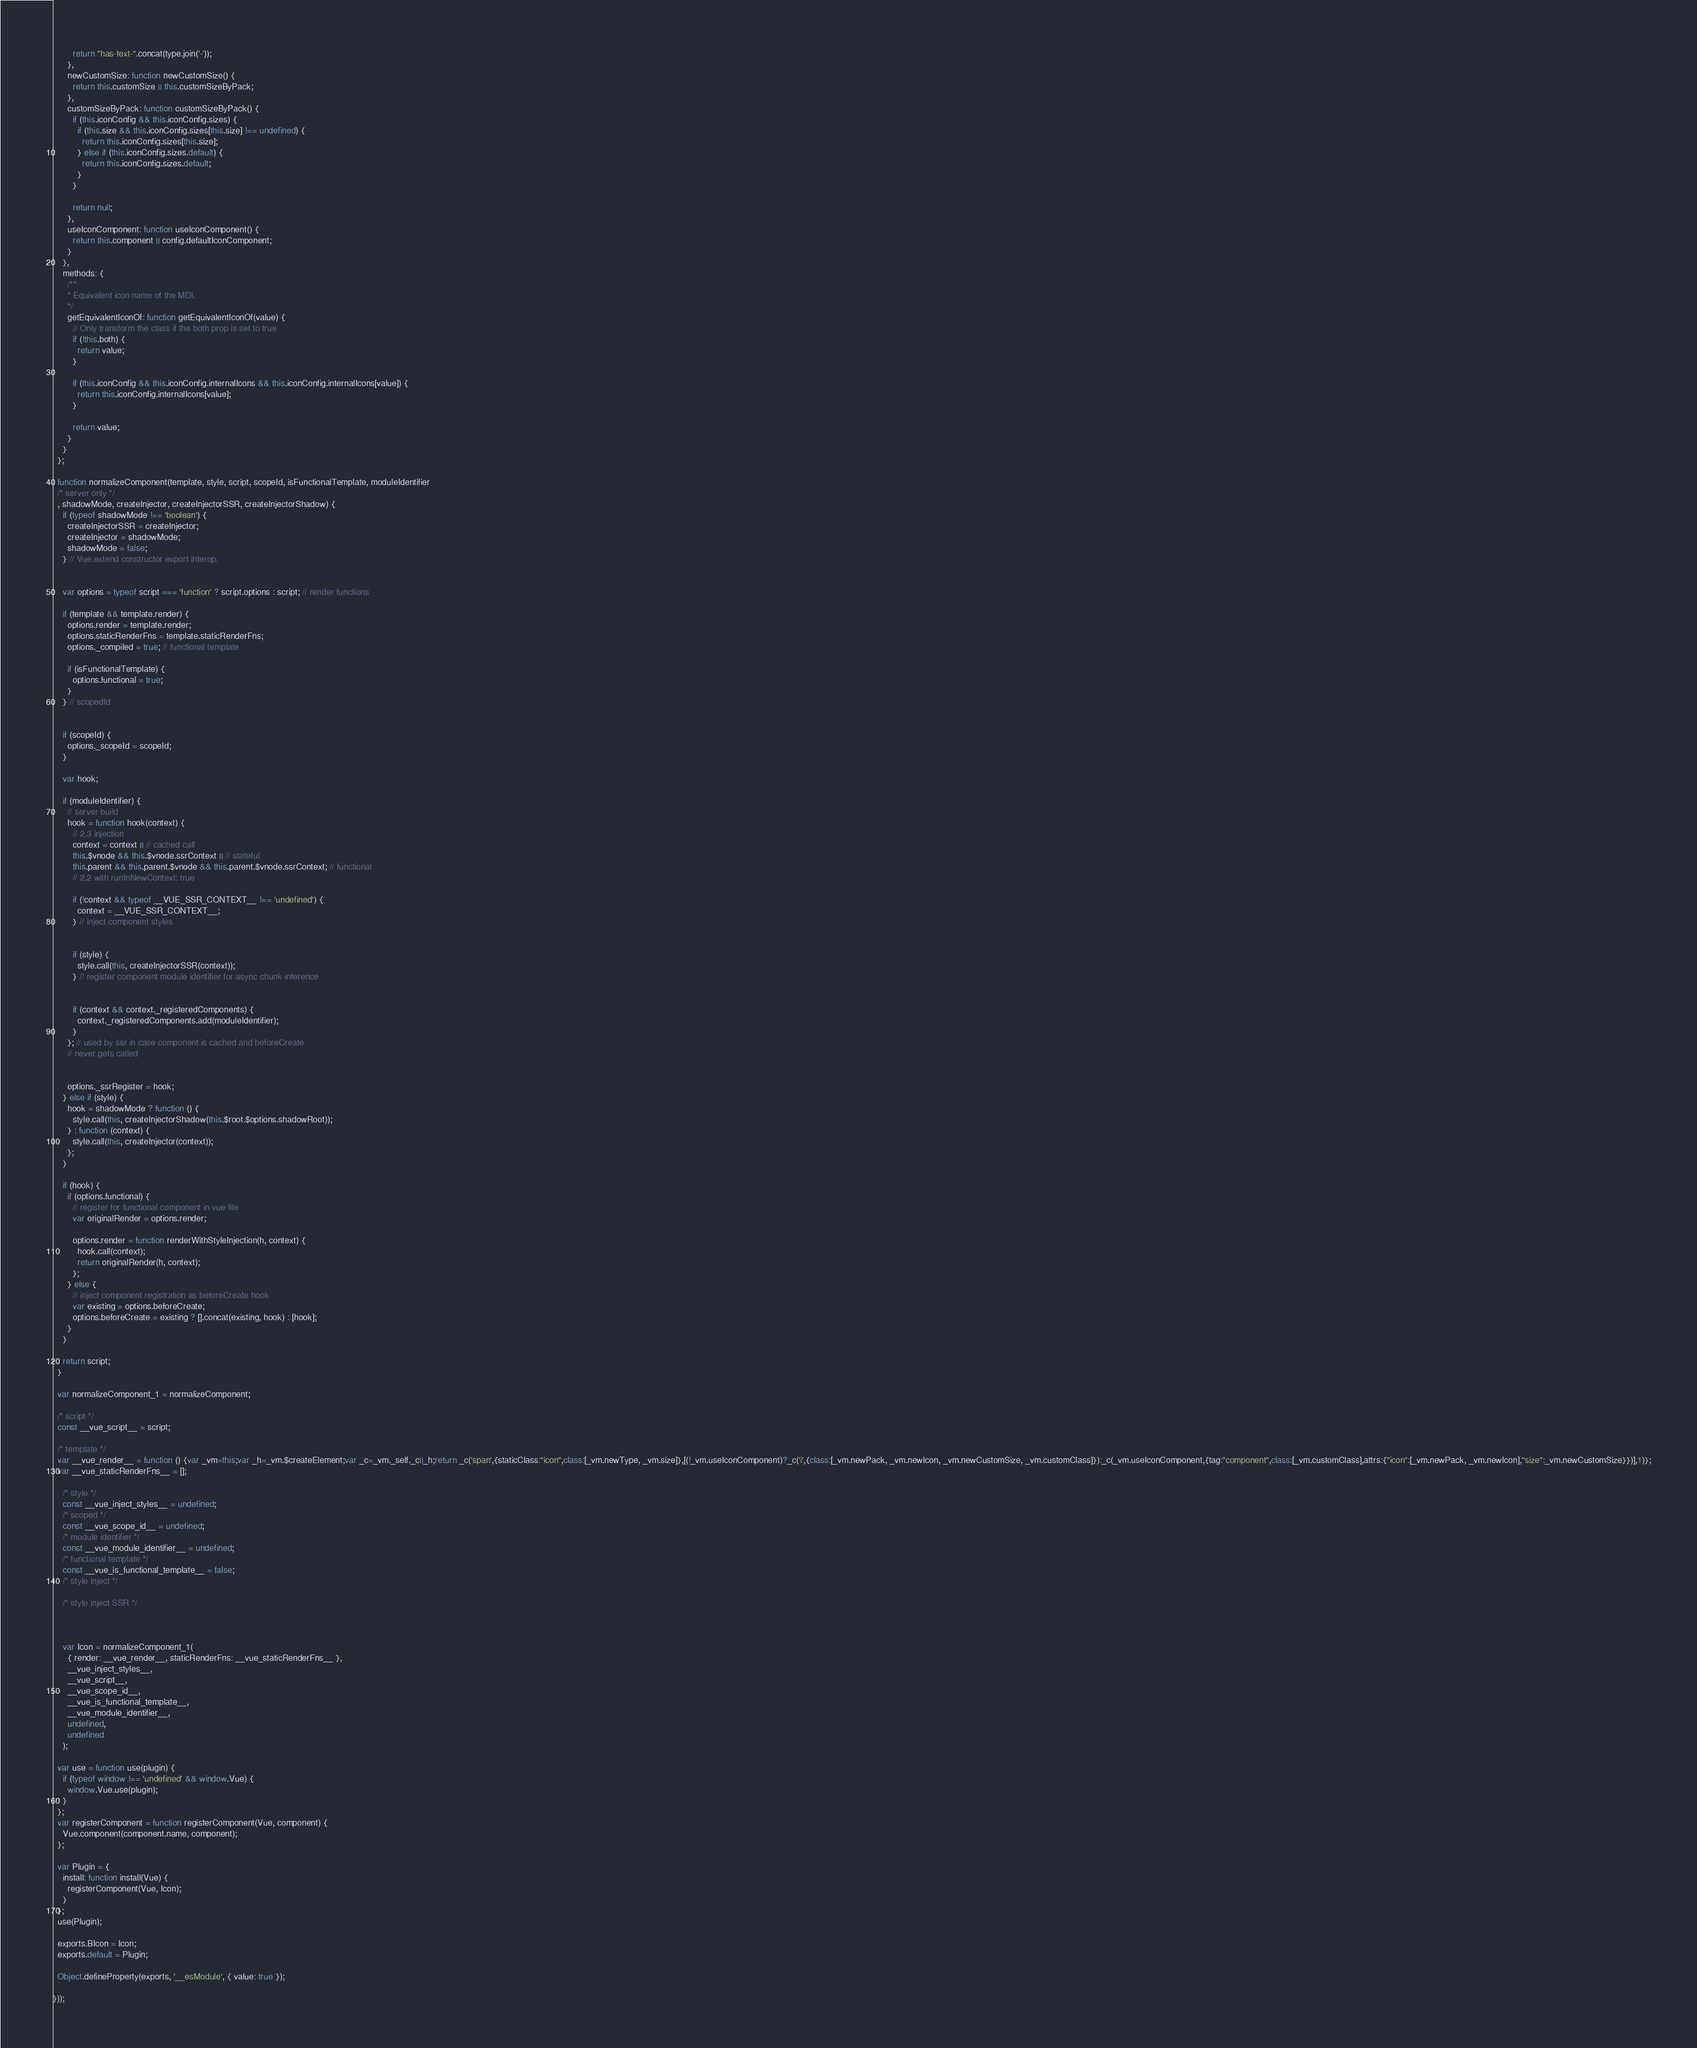<code> <loc_0><loc_0><loc_500><loc_500><_JavaScript_>
        return "has-text-".concat(type.join('-'));
      },
      newCustomSize: function newCustomSize() {
        return this.customSize || this.customSizeByPack;
      },
      customSizeByPack: function customSizeByPack() {
        if (this.iconConfig && this.iconConfig.sizes) {
          if (this.size && this.iconConfig.sizes[this.size] !== undefined) {
            return this.iconConfig.sizes[this.size];
          } else if (this.iconConfig.sizes.default) {
            return this.iconConfig.sizes.default;
          }
        }

        return null;
      },
      useIconComponent: function useIconComponent() {
        return this.component || config.defaultIconComponent;
      }
    },
    methods: {
      /**
      * Equivalent icon name of the MDI.
      */
      getEquivalentIconOf: function getEquivalentIconOf(value) {
        // Only transform the class if the both prop is set to true
        if (!this.both) {
          return value;
        }

        if (this.iconConfig && this.iconConfig.internalIcons && this.iconConfig.internalIcons[value]) {
          return this.iconConfig.internalIcons[value];
        }

        return value;
      }
    }
  };

  function normalizeComponent(template, style, script, scopeId, isFunctionalTemplate, moduleIdentifier
  /* server only */
  , shadowMode, createInjector, createInjectorSSR, createInjectorShadow) {
    if (typeof shadowMode !== 'boolean') {
      createInjectorSSR = createInjector;
      createInjector = shadowMode;
      shadowMode = false;
    } // Vue.extend constructor export interop.


    var options = typeof script === 'function' ? script.options : script; // render functions

    if (template && template.render) {
      options.render = template.render;
      options.staticRenderFns = template.staticRenderFns;
      options._compiled = true; // functional template

      if (isFunctionalTemplate) {
        options.functional = true;
      }
    } // scopedId


    if (scopeId) {
      options._scopeId = scopeId;
    }

    var hook;

    if (moduleIdentifier) {
      // server build
      hook = function hook(context) {
        // 2.3 injection
        context = context || // cached call
        this.$vnode && this.$vnode.ssrContext || // stateful
        this.parent && this.parent.$vnode && this.parent.$vnode.ssrContext; // functional
        // 2.2 with runInNewContext: true

        if (!context && typeof __VUE_SSR_CONTEXT__ !== 'undefined') {
          context = __VUE_SSR_CONTEXT__;
        } // inject component styles


        if (style) {
          style.call(this, createInjectorSSR(context));
        } // register component module identifier for async chunk inference


        if (context && context._registeredComponents) {
          context._registeredComponents.add(moduleIdentifier);
        }
      }; // used by ssr in case component is cached and beforeCreate
      // never gets called


      options._ssrRegister = hook;
    } else if (style) {
      hook = shadowMode ? function () {
        style.call(this, createInjectorShadow(this.$root.$options.shadowRoot));
      } : function (context) {
        style.call(this, createInjector(context));
      };
    }

    if (hook) {
      if (options.functional) {
        // register for functional component in vue file
        var originalRender = options.render;

        options.render = function renderWithStyleInjection(h, context) {
          hook.call(context);
          return originalRender(h, context);
        };
      } else {
        // inject component registration as beforeCreate hook
        var existing = options.beforeCreate;
        options.beforeCreate = existing ? [].concat(existing, hook) : [hook];
      }
    }

    return script;
  }

  var normalizeComponent_1 = normalizeComponent;

  /* script */
  const __vue_script__ = script;

  /* template */
  var __vue_render__ = function () {var _vm=this;var _h=_vm.$createElement;var _c=_vm._self._c||_h;return _c('span',{staticClass:"icon",class:[_vm.newType, _vm.size]},[(!_vm.useIconComponent)?_c('i',{class:[_vm.newPack, _vm.newIcon, _vm.newCustomSize, _vm.customClass]}):_c(_vm.useIconComponent,{tag:"component",class:[_vm.customClass],attrs:{"icon":[_vm.newPack, _vm.newIcon],"size":_vm.newCustomSize}})],1)};
  var __vue_staticRenderFns__ = [];

    /* style */
    const __vue_inject_styles__ = undefined;
    /* scoped */
    const __vue_scope_id__ = undefined;
    /* module identifier */
    const __vue_module_identifier__ = undefined;
    /* functional template */
    const __vue_is_functional_template__ = false;
    /* style inject */
    
    /* style inject SSR */
    

    
    var Icon = normalizeComponent_1(
      { render: __vue_render__, staticRenderFns: __vue_staticRenderFns__ },
      __vue_inject_styles__,
      __vue_script__,
      __vue_scope_id__,
      __vue_is_functional_template__,
      __vue_module_identifier__,
      undefined,
      undefined
    );

  var use = function use(plugin) {
    if (typeof window !== 'undefined' && window.Vue) {
      window.Vue.use(plugin);
    }
  };
  var registerComponent = function registerComponent(Vue, component) {
    Vue.component(component.name, component);
  };

  var Plugin = {
    install: function install(Vue) {
      registerComponent(Vue, Icon);
    }
  };
  use(Plugin);

  exports.BIcon = Icon;
  exports.default = Plugin;

  Object.defineProperty(exports, '__esModule', { value: true });

}));
</code> 